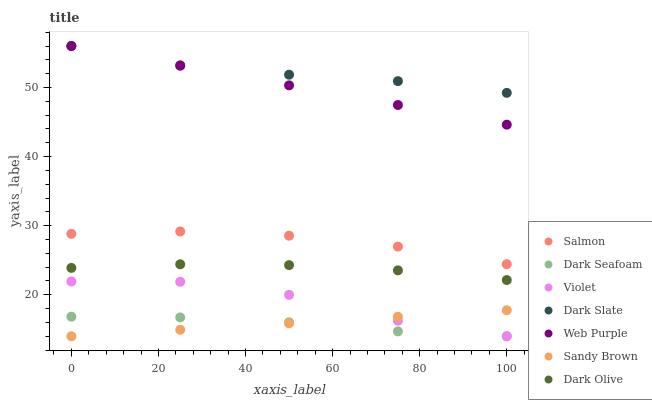Does Dark Seafoam have the minimum area under the curve?
Answer yes or no. Yes. Does Dark Slate have the maximum area under the curve?
Answer yes or no. Yes. Does Salmon have the minimum area under the curve?
Answer yes or no. No. Does Salmon have the maximum area under the curve?
Answer yes or no. No. Is Sandy Brown the smoothest?
Answer yes or no. Yes. Is Violet the roughest?
Answer yes or no. Yes. Is Salmon the smoothest?
Answer yes or no. No. Is Salmon the roughest?
Answer yes or no. No. Does Dark Seafoam have the lowest value?
Answer yes or no. Yes. Does Salmon have the lowest value?
Answer yes or no. No. Does Dark Slate have the highest value?
Answer yes or no. Yes. Does Salmon have the highest value?
Answer yes or no. No. Is Salmon less than Dark Slate?
Answer yes or no. Yes. Is Web Purple greater than Dark Olive?
Answer yes or no. Yes. Does Sandy Brown intersect Violet?
Answer yes or no. Yes. Is Sandy Brown less than Violet?
Answer yes or no. No. Is Sandy Brown greater than Violet?
Answer yes or no. No. Does Salmon intersect Dark Slate?
Answer yes or no. No. 